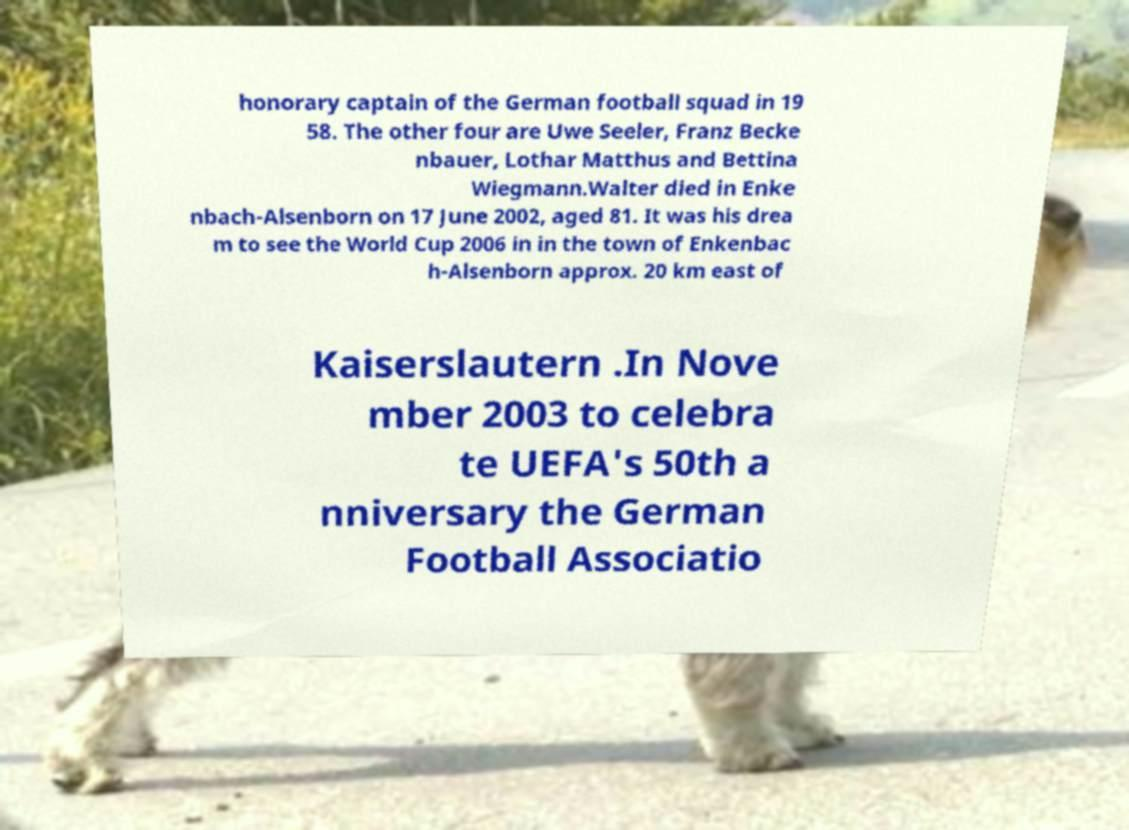Could you extract and type out the text from this image? honorary captain of the German football squad in 19 58. The other four are Uwe Seeler, Franz Becke nbauer, Lothar Matthus and Bettina Wiegmann.Walter died in Enke nbach-Alsenborn on 17 June 2002, aged 81. It was his drea m to see the World Cup 2006 in in the town of Enkenbac h-Alsenborn approx. 20 km east of Kaiserslautern .In Nove mber 2003 to celebra te UEFA's 50th a nniversary the German Football Associatio 